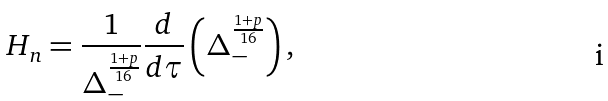<formula> <loc_0><loc_0><loc_500><loc_500>H _ { n } = \frac { 1 } { \Delta _ { - } ^ { \frac { 1 + p } { 1 6 } } } \frac { d } { d \tau } \left ( \Delta _ { - } ^ { \frac { 1 + p } { 1 6 } } \right ) ,</formula> 